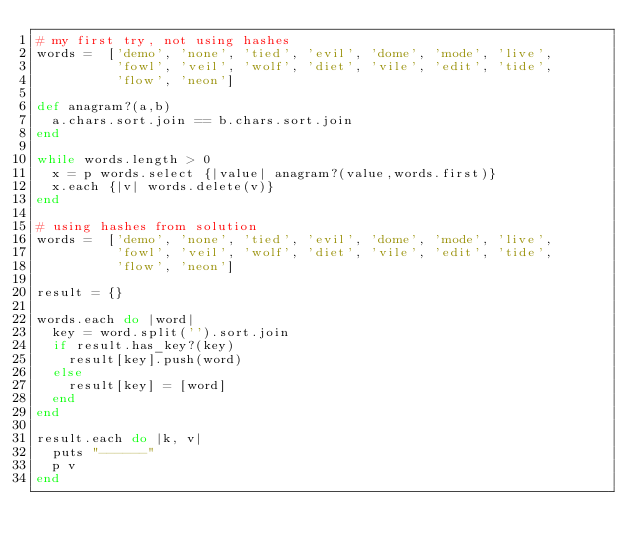Convert code to text. <code><loc_0><loc_0><loc_500><loc_500><_Ruby_># my first try, not using hashes
words =  ['demo', 'none', 'tied', 'evil', 'dome', 'mode', 'live',
          'fowl', 'veil', 'wolf', 'diet', 'vile', 'edit', 'tide',
          'flow', 'neon']
          
def anagram?(a,b)
  a.chars.sort.join == b.chars.sort.join
end

while words.length > 0
  x = p words.select {|value| anagram?(value,words.first)}
  x.each {|v| words.delete(v)}
end

# using hashes from solution
words =  ['demo', 'none', 'tied', 'evil', 'dome', 'mode', 'live',
          'fowl', 'veil', 'wolf', 'diet', 'vile', 'edit', 'tide',
          'flow', 'neon']
          
result = {}

words.each do |word|
  key = word.split('').sort.join
  if result.has_key?(key)
    result[key].push(word)
  else
    result[key] = [word]
  end
end

result.each do |k, v|
  puts "------"
  p v
end</code> 